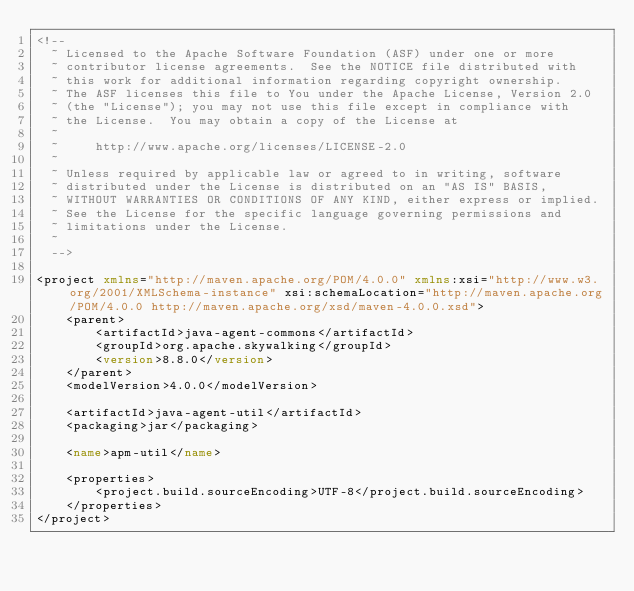<code> <loc_0><loc_0><loc_500><loc_500><_XML_><!--
  ~ Licensed to the Apache Software Foundation (ASF) under one or more
  ~ contributor license agreements.  See the NOTICE file distributed with
  ~ this work for additional information regarding copyright ownership.
  ~ The ASF licenses this file to You under the Apache License, Version 2.0
  ~ (the "License"); you may not use this file except in compliance with
  ~ the License.  You may obtain a copy of the License at
  ~
  ~     http://www.apache.org/licenses/LICENSE-2.0
  ~
  ~ Unless required by applicable law or agreed to in writing, software
  ~ distributed under the License is distributed on an "AS IS" BASIS,
  ~ WITHOUT WARRANTIES OR CONDITIONS OF ANY KIND, either express or implied.
  ~ See the License for the specific language governing permissions and
  ~ limitations under the License.
  ~
  -->

<project xmlns="http://maven.apache.org/POM/4.0.0" xmlns:xsi="http://www.w3.org/2001/XMLSchema-instance" xsi:schemaLocation="http://maven.apache.org/POM/4.0.0 http://maven.apache.org/xsd/maven-4.0.0.xsd">
    <parent>
        <artifactId>java-agent-commons</artifactId>
        <groupId>org.apache.skywalking</groupId>
        <version>8.8.0</version>
    </parent>
    <modelVersion>4.0.0</modelVersion>

    <artifactId>java-agent-util</artifactId>
    <packaging>jar</packaging>

    <name>apm-util</name>

    <properties>
        <project.build.sourceEncoding>UTF-8</project.build.sourceEncoding>
    </properties>
</project>
</code> 